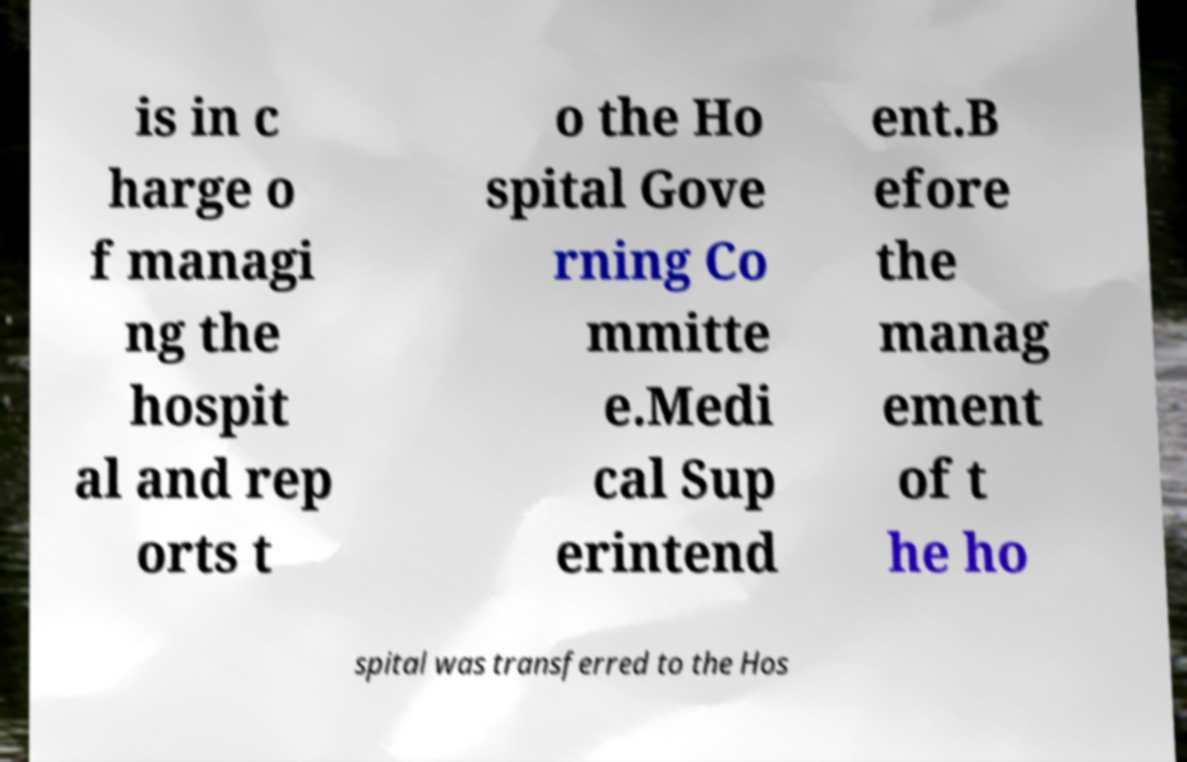Could you extract and type out the text from this image? is in c harge o f managi ng the hospit al and rep orts t o the Ho spital Gove rning Co mmitte e.Medi cal Sup erintend ent.B efore the manag ement of t he ho spital was transferred to the Hos 